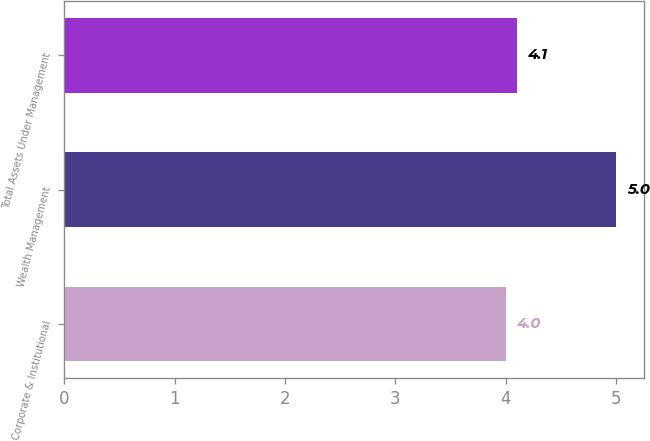Convert chart to OTSL. <chart><loc_0><loc_0><loc_500><loc_500><bar_chart><fcel>Corporate & Institutional<fcel>Wealth Management<fcel>Total Assets Under Management<nl><fcel>4<fcel>5<fcel>4.1<nl></chart> 